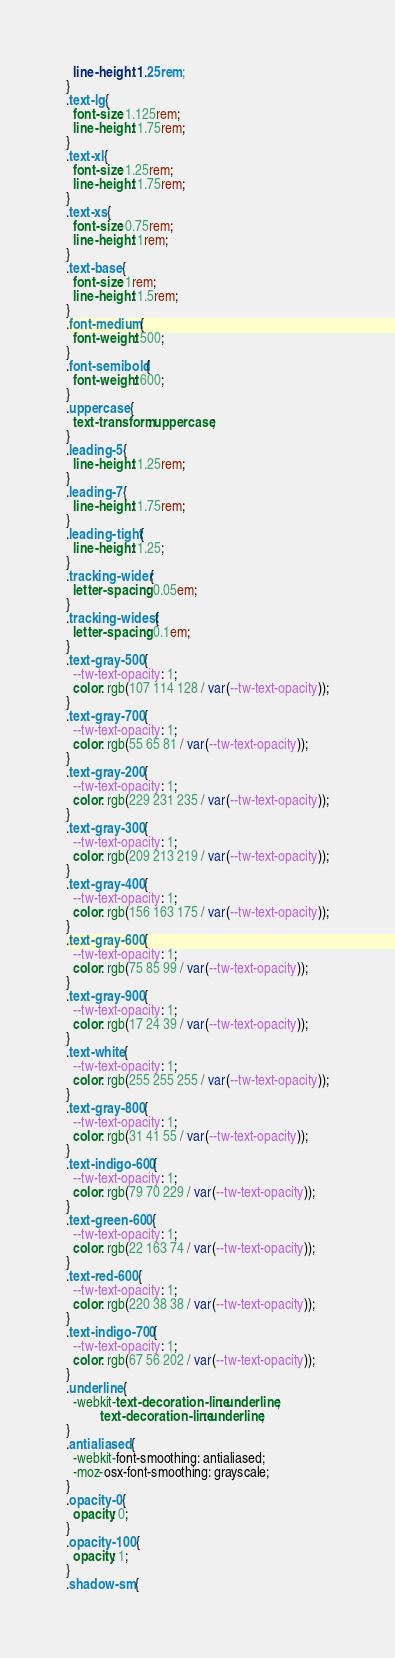<code> <loc_0><loc_0><loc_500><loc_500><_CSS_>  line-height: 1.25rem;
}
.text-lg {
  font-size: 1.125rem;
  line-height: 1.75rem;
}
.text-xl {
  font-size: 1.25rem;
  line-height: 1.75rem;
}
.text-xs {
  font-size: 0.75rem;
  line-height: 1rem;
}
.text-base {
  font-size: 1rem;
  line-height: 1.5rem;
}
.font-medium {
  font-weight: 500;
}
.font-semibold {
  font-weight: 600;
}
.uppercase {
  text-transform: uppercase;
}
.leading-5 {
  line-height: 1.25rem;
}
.leading-7 {
  line-height: 1.75rem;
}
.leading-tight {
  line-height: 1.25;
}
.tracking-wider {
  letter-spacing: 0.05em;
}
.tracking-widest {
  letter-spacing: 0.1em;
}
.text-gray-500 {
  --tw-text-opacity: 1;
  color: rgb(107 114 128 / var(--tw-text-opacity));
}
.text-gray-700 {
  --tw-text-opacity: 1;
  color: rgb(55 65 81 / var(--tw-text-opacity));
}
.text-gray-200 {
  --tw-text-opacity: 1;
  color: rgb(229 231 235 / var(--tw-text-opacity));
}
.text-gray-300 {
  --tw-text-opacity: 1;
  color: rgb(209 213 219 / var(--tw-text-opacity));
}
.text-gray-400 {
  --tw-text-opacity: 1;
  color: rgb(156 163 175 / var(--tw-text-opacity));
}
.text-gray-600 {
  --tw-text-opacity: 1;
  color: rgb(75 85 99 / var(--tw-text-opacity));
}
.text-gray-900 {
  --tw-text-opacity: 1;
  color: rgb(17 24 39 / var(--tw-text-opacity));
}
.text-white {
  --tw-text-opacity: 1;
  color: rgb(255 255 255 / var(--tw-text-opacity));
}
.text-gray-800 {
  --tw-text-opacity: 1;
  color: rgb(31 41 55 / var(--tw-text-opacity));
}
.text-indigo-600 {
  --tw-text-opacity: 1;
  color: rgb(79 70 229 / var(--tw-text-opacity));
}
.text-green-600 {
  --tw-text-opacity: 1;
  color: rgb(22 163 74 / var(--tw-text-opacity));
}
.text-red-600 {
  --tw-text-opacity: 1;
  color: rgb(220 38 38 / var(--tw-text-opacity));
}
.text-indigo-700 {
  --tw-text-opacity: 1;
  color: rgb(67 56 202 / var(--tw-text-opacity));
}
.underline {
  -webkit-text-decoration-line: underline;
          text-decoration-line: underline;
}
.antialiased {
  -webkit-font-smoothing: antialiased;
  -moz-osx-font-smoothing: grayscale;
}
.opacity-0 {
  opacity: 0;
}
.opacity-100 {
  opacity: 1;
}
.shadow-sm {</code> 